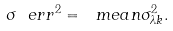<formula> <loc_0><loc_0><loc_500><loc_500>\sigma _ { \ } e r r ^ { 2 } = \ m e a n { \sigma ^ { 2 } _ { \lambda k } } .</formula> 